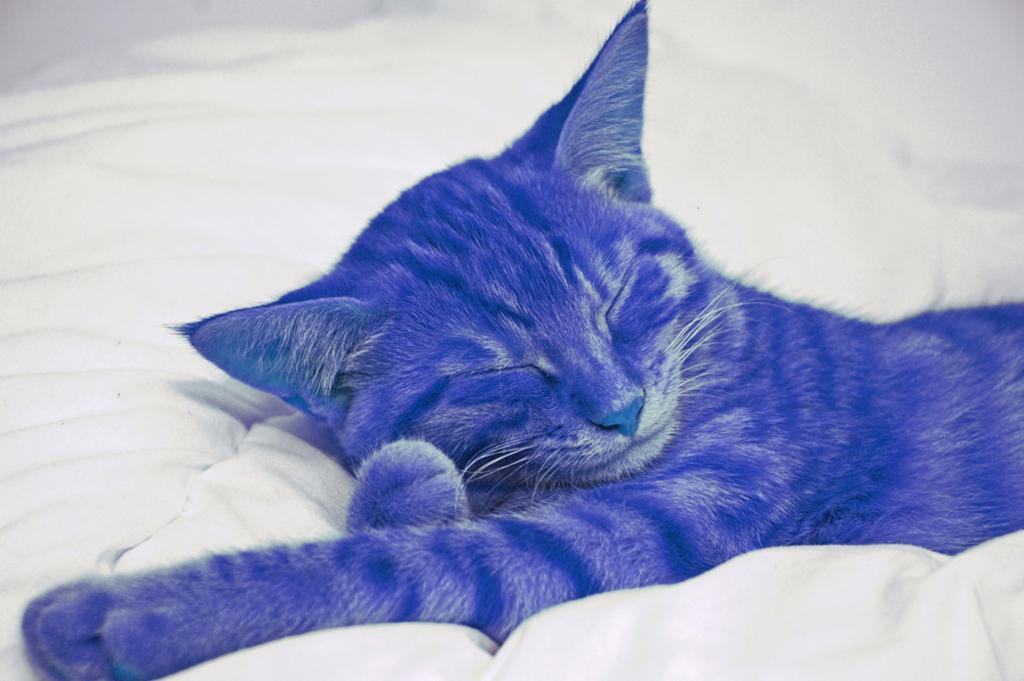What type of animal is in the image? There is a blue color cat in the image. What is the cat doing in the image? The cat is sleeping. Where is the cat located in the image? The cat is on a bed. What type of stage is the cat performing on in the image? There is no stage present in the image, and the cat is not performing; it is sleeping on a bed. 